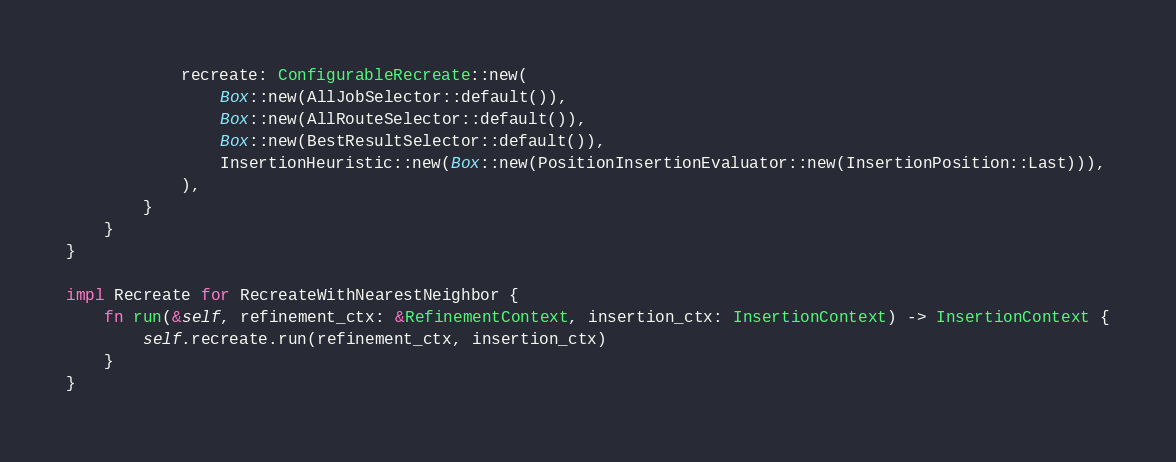Convert code to text. <code><loc_0><loc_0><loc_500><loc_500><_Rust_>            recreate: ConfigurableRecreate::new(
                Box::new(AllJobSelector::default()),
                Box::new(AllRouteSelector::default()),
                Box::new(BestResultSelector::default()),
                InsertionHeuristic::new(Box::new(PositionInsertionEvaluator::new(InsertionPosition::Last))),
            ),
        }
    }
}

impl Recreate for RecreateWithNearestNeighbor {
    fn run(&self, refinement_ctx: &RefinementContext, insertion_ctx: InsertionContext) -> InsertionContext {
        self.recreate.run(refinement_ctx, insertion_ctx)
    }
}
</code> 